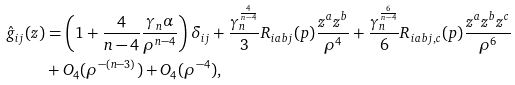Convert formula to latex. <formula><loc_0><loc_0><loc_500><loc_500>\hat { g } _ { i j } ( z ) & = \left ( 1 + \frac { 4 } { n - 4 } \frac { \gamma _ { n } \alpha } { \rho ^ { n - 4 } } \right ) \delta _ { i j } + \frac { \gamma ^ { \frac { 4 } { n - 4 } } _ { n } } { 3 } R _ { i a b j } ( p ) \frac { z ^ { a } z ^ { b } } { \rho ^ { 4 } } + \frac { \gamma ^ { \frac { 6 } { n - 4 } } _ { n } } { 6 } R _ { i a b j , c } ( p ) \frac { z ^ { a } z ^ { b } z ^ { c } } { \rho ^ { 6 } } \\ & + O _ { 4 } ( \rho ^ { - ( n - 3 ) } ) + O _ { 4 } ( \rho ^ { - 4 } ) ,</formula> 